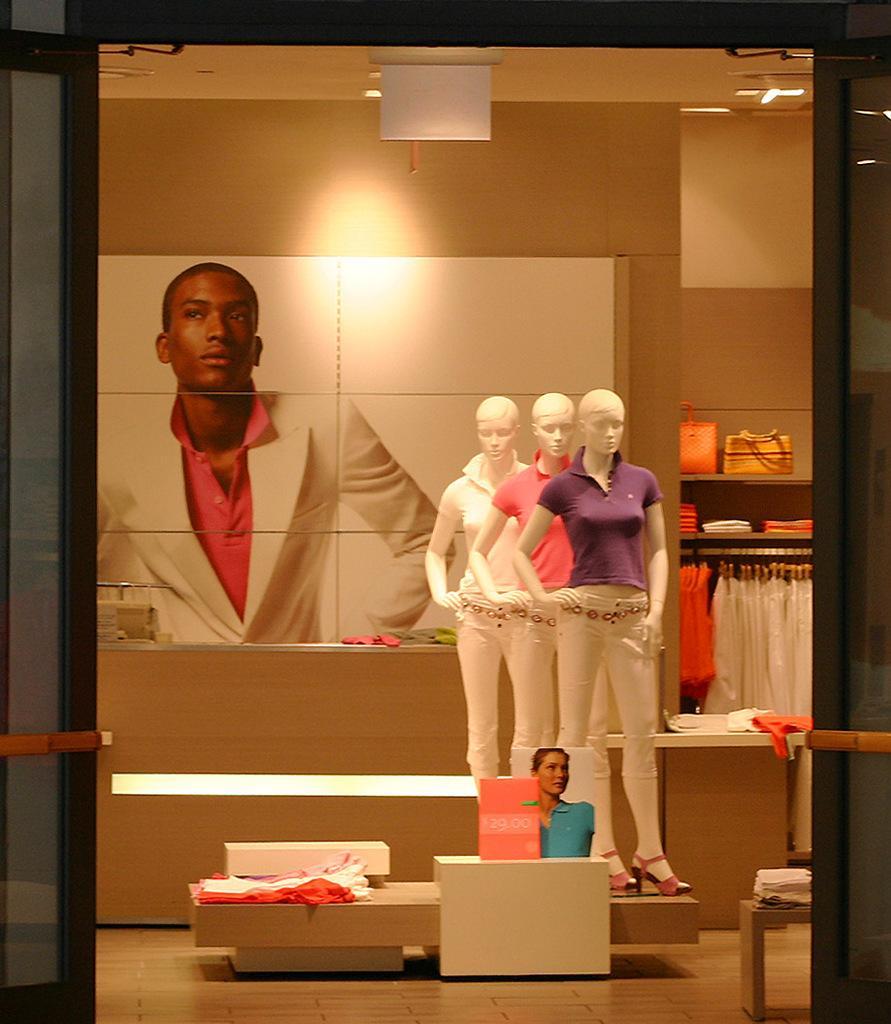Describe this image in one or two sentences. In this image I can see three mannequins of a shop. I can see some clothes hanging on the right hand side of the image I can see some leather bags on the shelf. I can see a board with the photograph of a person. I can see some clothes and other objects on the table and a board with a photograph of a woman. 